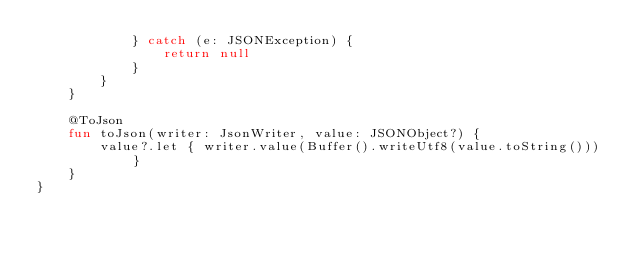<code> <loc_0><loc_0><loc_500><loc_500><_Kotlin_>            } catch (e: JSONException) {
                return null
            }
        }
    }

    @ToJson
    fun toJson(writer: JsonWriter, value: JSONObject?) {
        value?.let { writer.value(Buffer().writeUtf8(value.toString())) }
    }
}</code> 